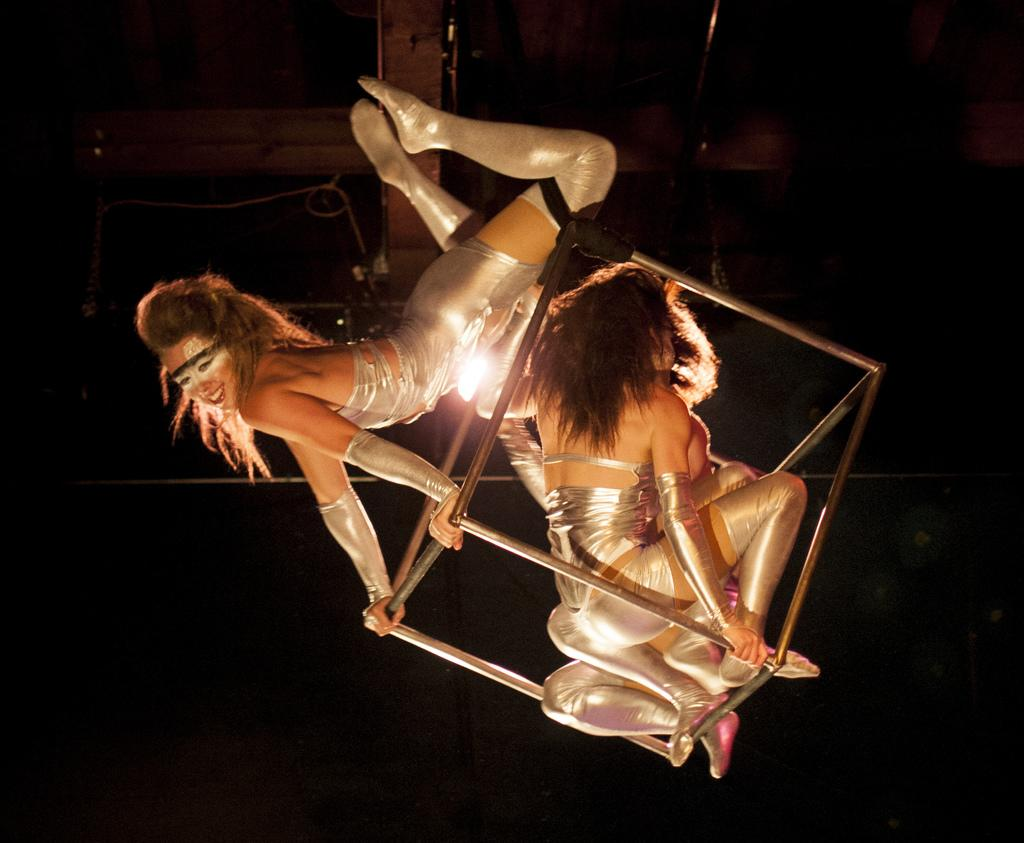How many people are in the image? There are three women in the image. What are the women doing in the image? The women are doing stunts in the image. What can be seen above the women in the image? There is a ceiling visible in the image. What type of objects are present in the image? There are wooden poles in the image. What type of thumb is being used to stop the stunt in the image? There is no thumb or stunt being stopped in the image; the women are performing stunts without using their thumbs to stop them. 